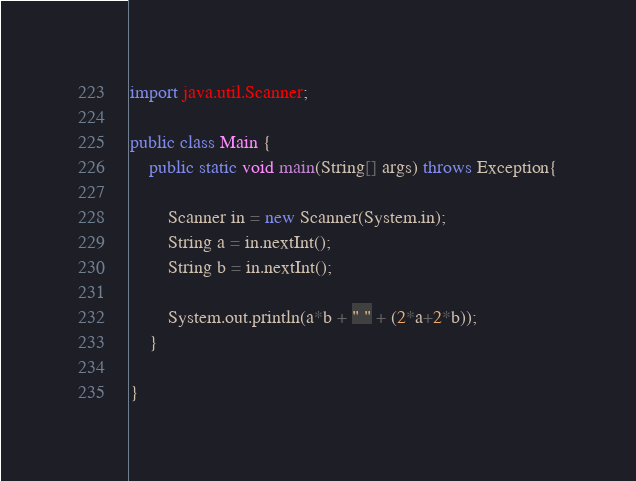<code> <loc_0><loc_0><loc_500><loc_500><_Java_>
import java.util.Scanner;
 
public class Main {
    public static void main(String[] args) throws Exception{
    
        Scanner in = new Scanner(System.in);
        String a = in.nextInt();
        String b = in.nextInt();
        
        System.out.println(a*b + " " + (2*a+2*b));
    }
    
}</code> 